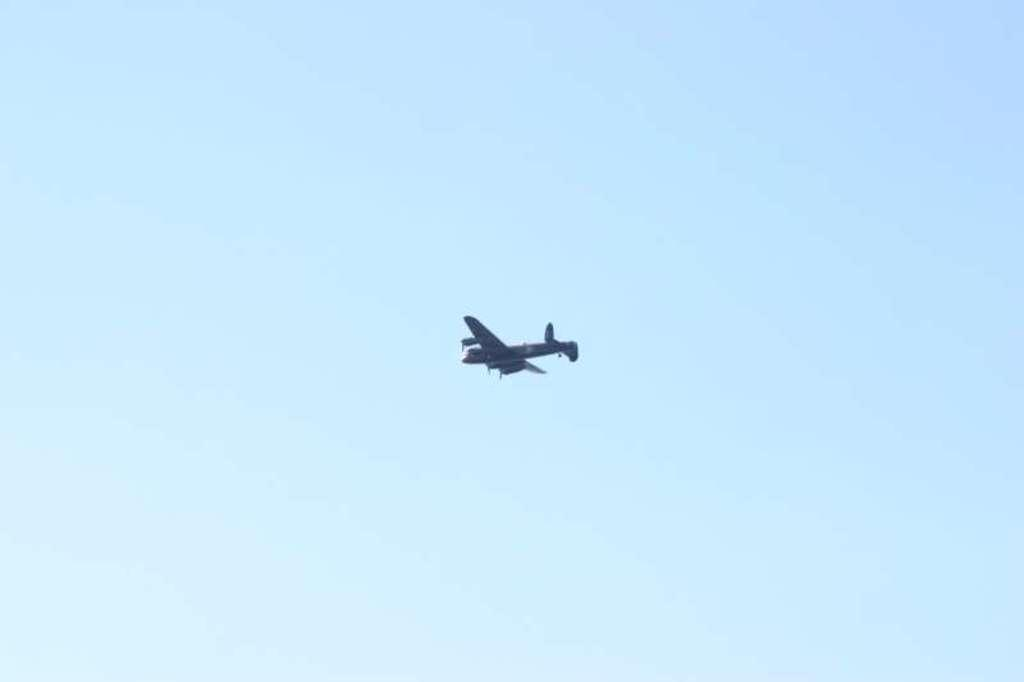What is the main subject of the image? There is an aircraft in the center of the image. What type of guitar can be seen being played by the butter in the image? There is no guitar or butter present in the image; it only features an aircraft. 